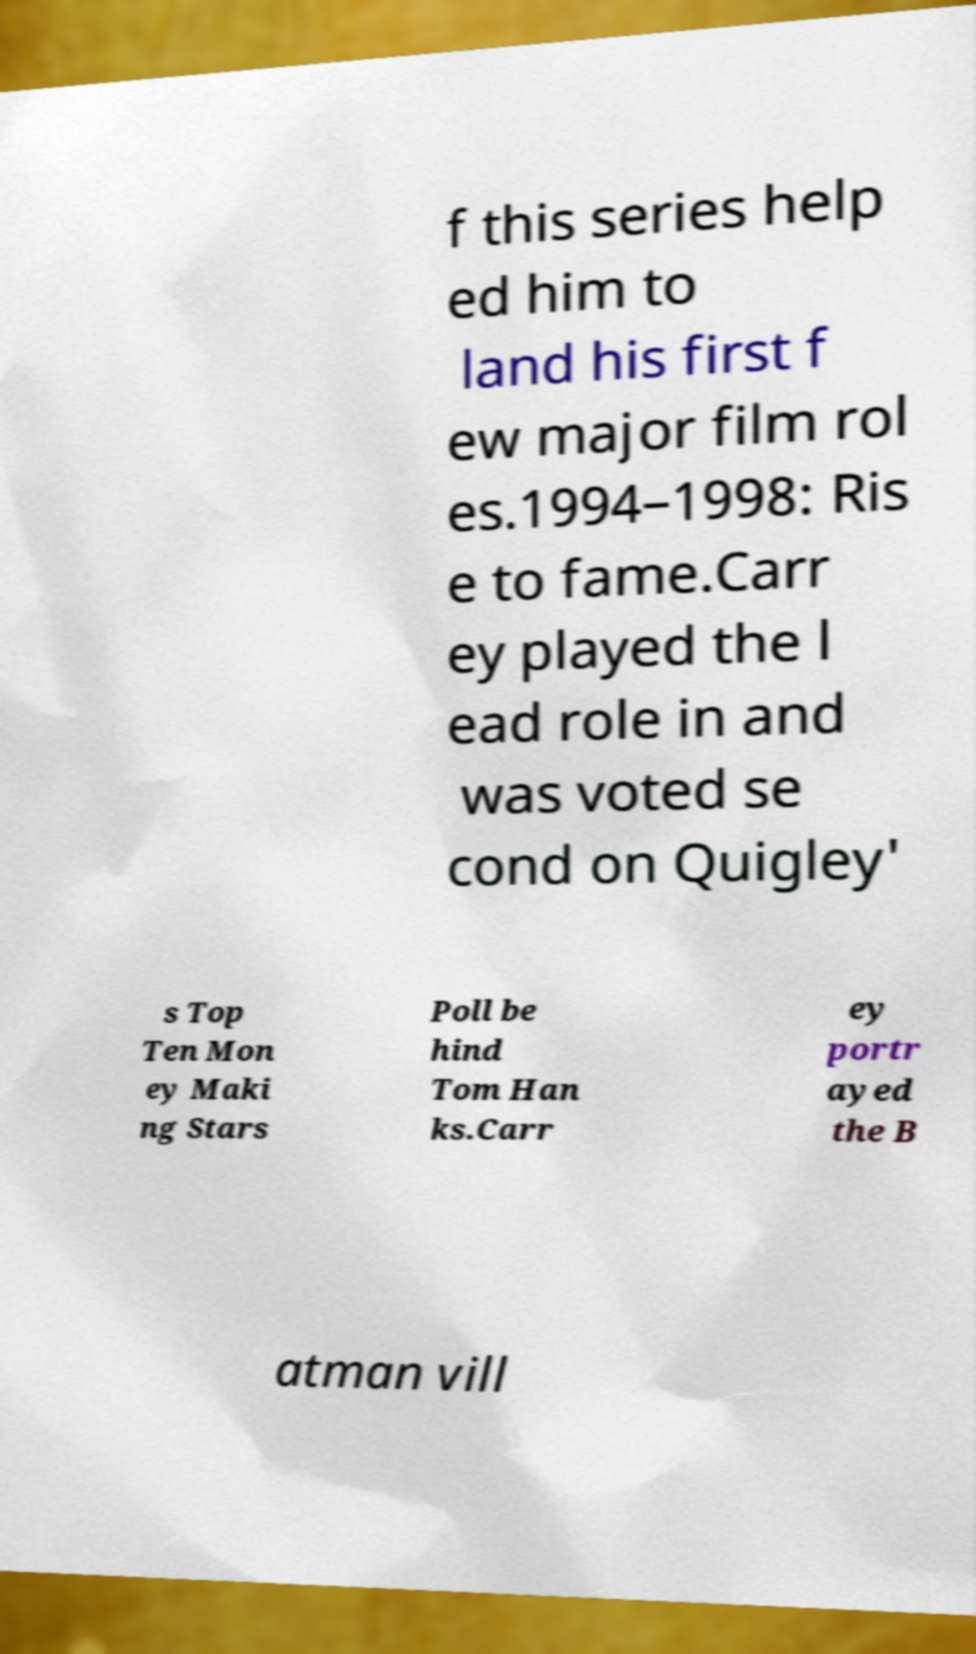I need the written content from this picture converted into text. Can you do that? f this series help ed him to land his first f ew major film rol es.1994–1998: Ris e to fame.Carr ey played the l ead role in and was voted se cond on Quigley' s Top Ten Mon ey Maki ng Stars Poll be hind Tom Han ks.Carr ey portr ayed the B atman vill 